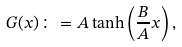Convert formula to latex. <formula><loc_0><loc_0><loc_500><loc_500>G ( x ) \colon = A \tanh \left ( \frac { B } { A } x \right ) ,</formula> 